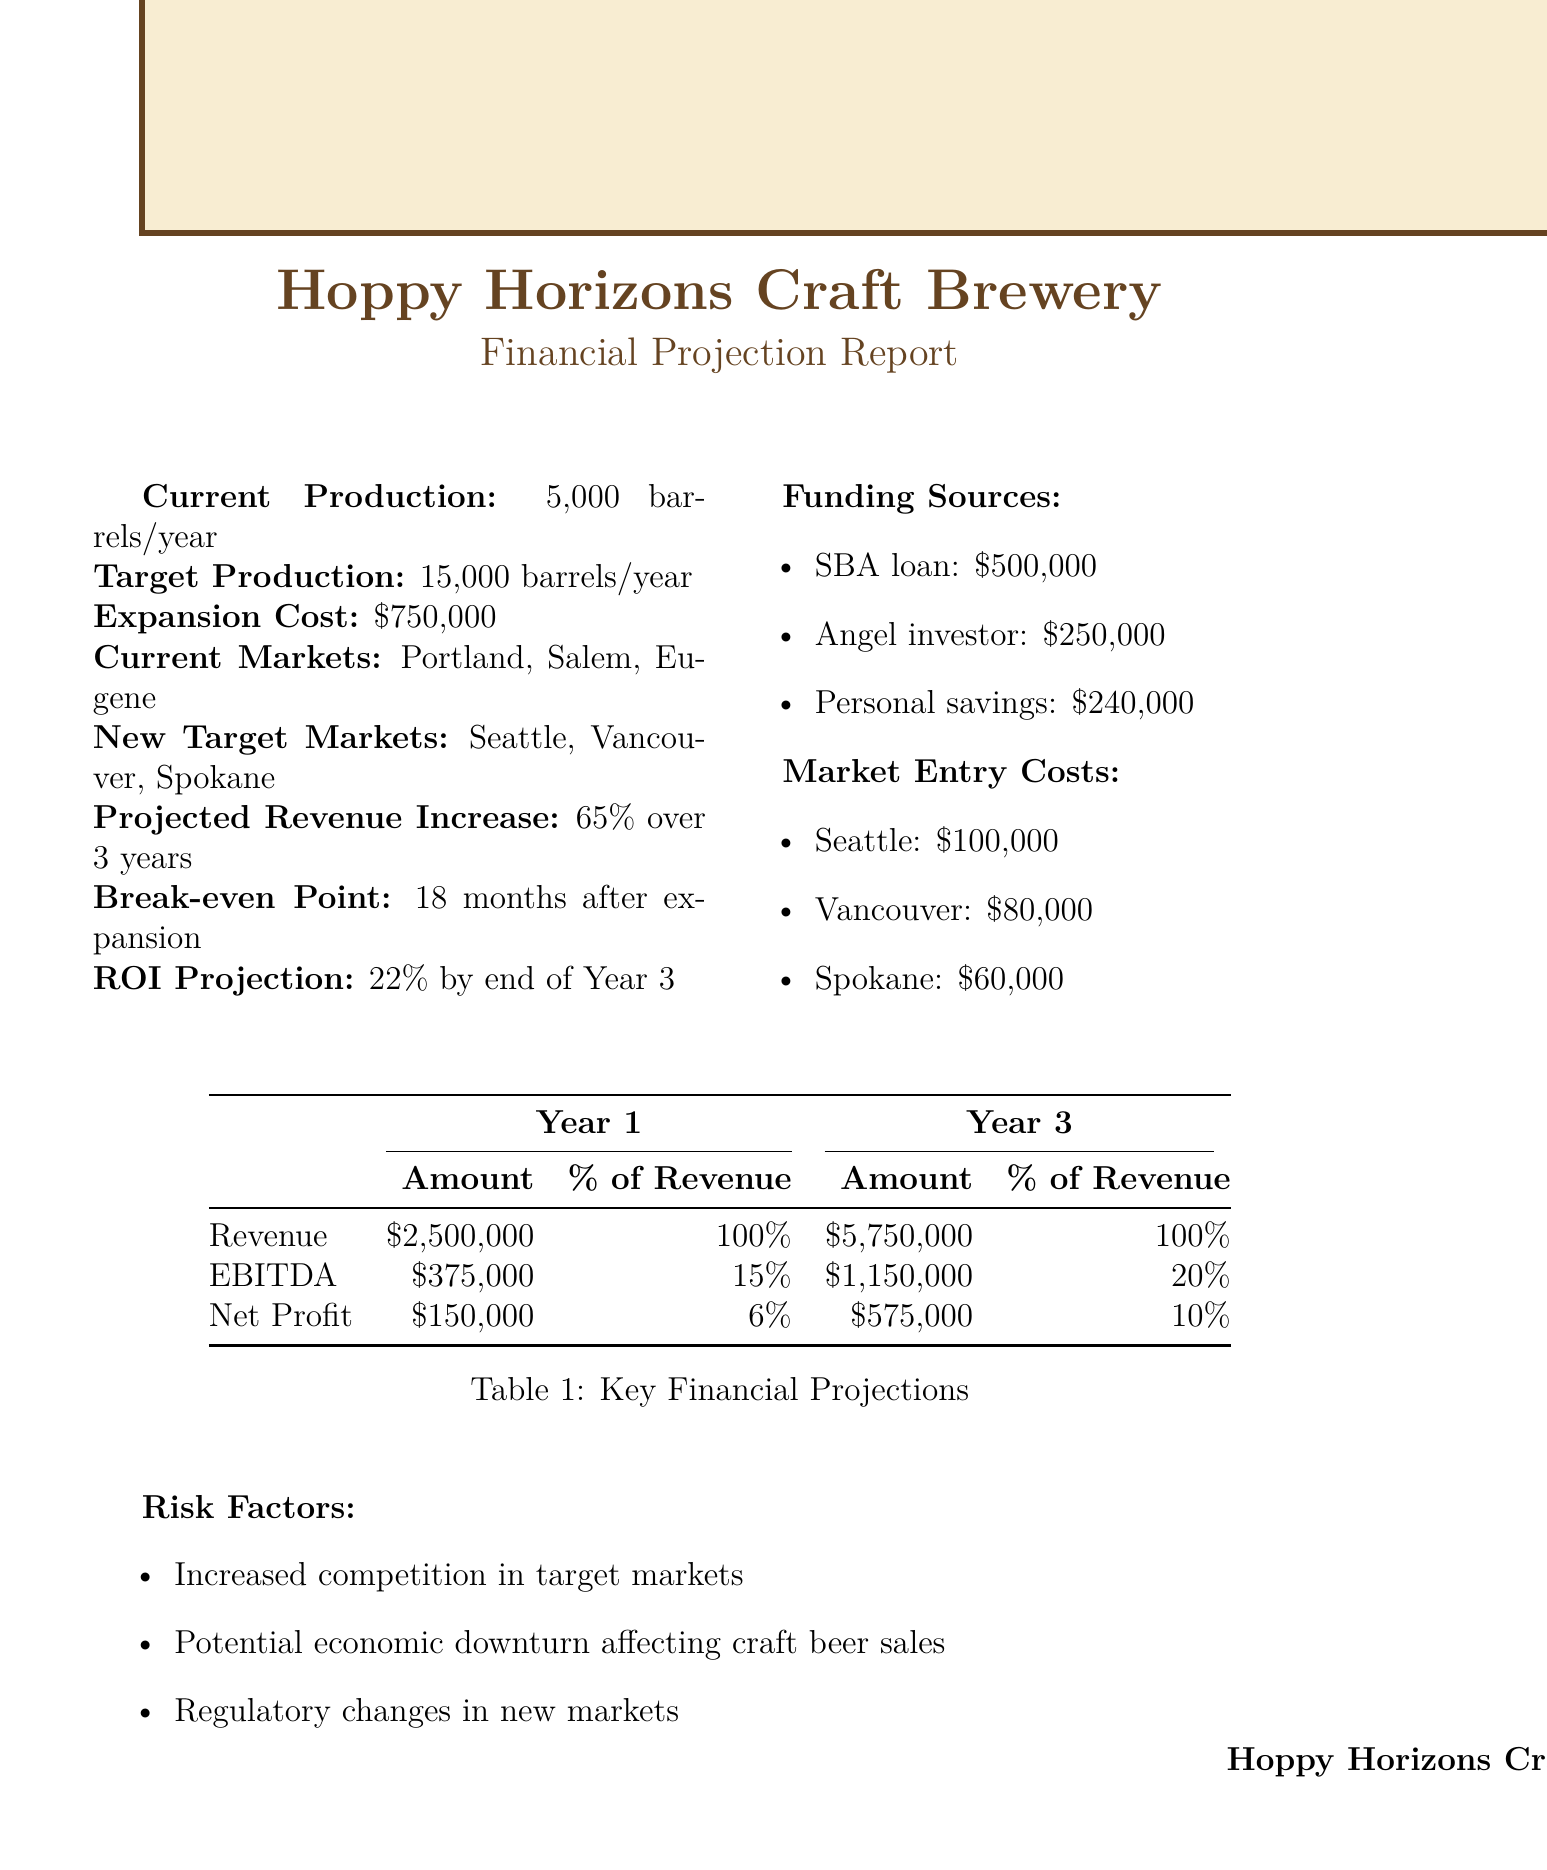What is the current production capacity? The current production capacity is stated explicitly in the document.
Answer: 5,000 barrels per year What is the target production capacity? The target production capacity is provided in the report as the planned increase in production.
Answer: 15,000 barrels per year What is the total expansion cost? The expansion cost is clearly listed in the document, defining the investment needed for the increase.
Answer: $750,000 Which new market has the highest estimated market entry cost? By comparing the market entry costs provided, one can determine which market has the highest cost.
Answer: Seattle What is the projected revenue increase over three years? The projected revenue increase is outlined in the financial projection report based on market expansion.
Answer: 65% over 3 years What is the break-even point after expansion? The break-even point is mentioned in the report as the time required to recover the investment.
Answer: 18 months after expansion What is the net profit in Year 3? The net profit figure is detailed in the key financial projections section for Year 3.
Answer: $575,000 What percentage of revenue is the EBITDA in Year 1? The percentage of revenue related to EBITDA in Year 1 is provided in the financial table.
Answer: 15% What is the ROI projection by the end of Year 3? The return on investment projection is specified in the document, reflecting financial performance.
Answer: 22% by end of Year 3 